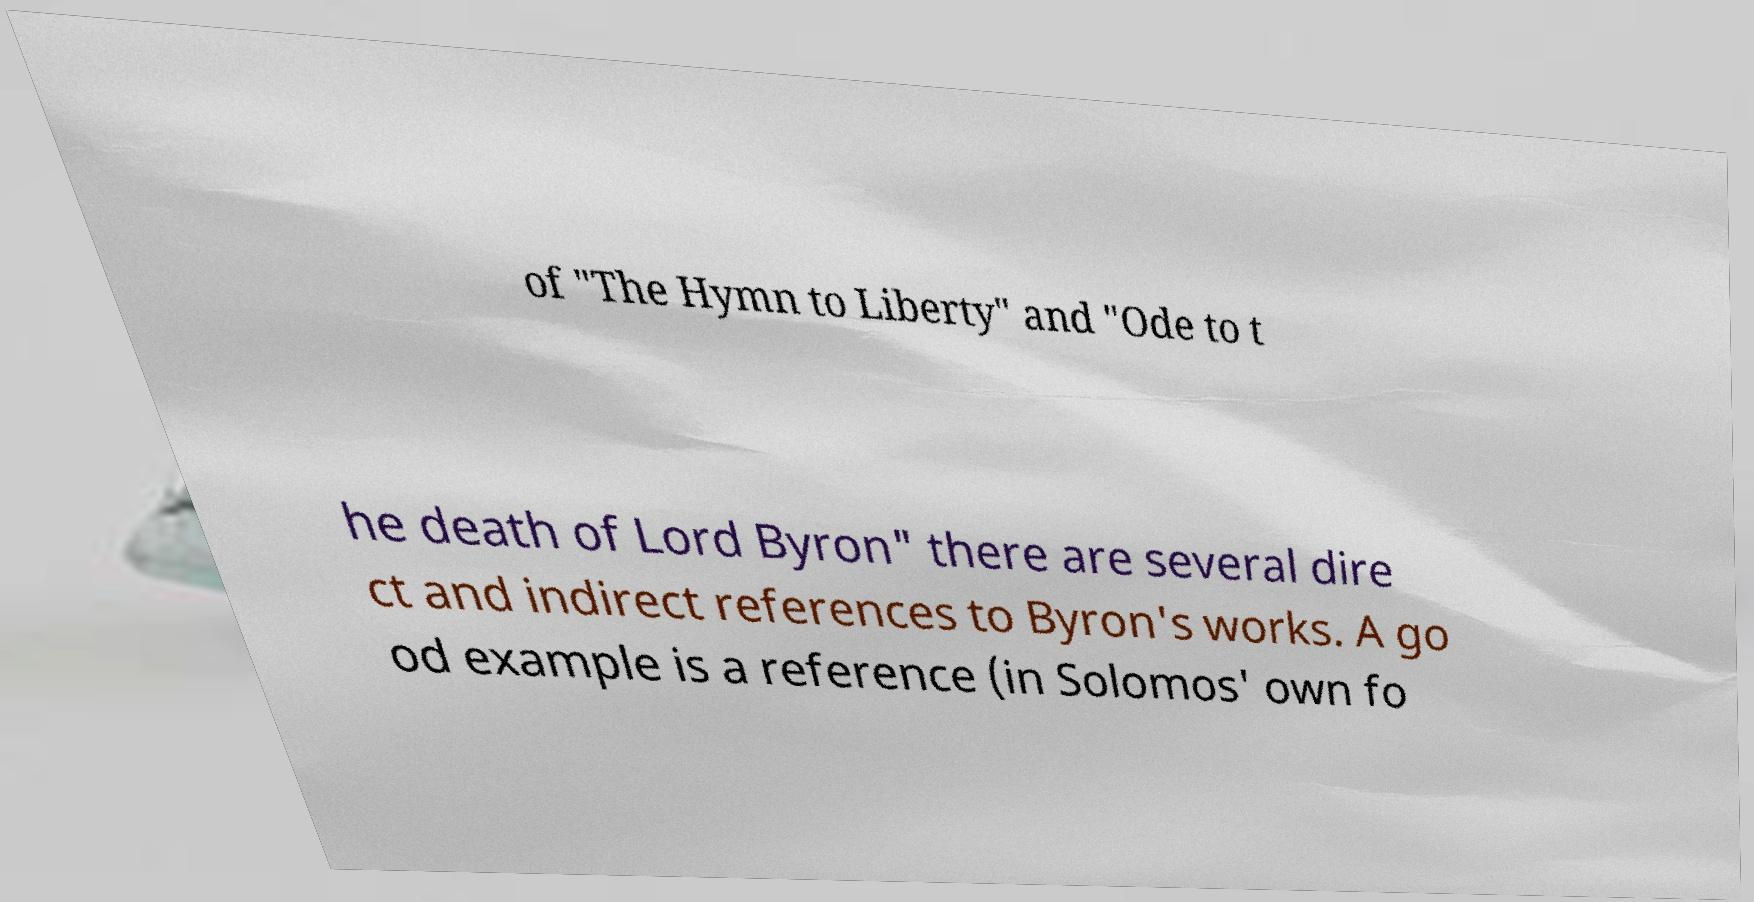Can you read and provide the text displayed in the image?This photo seems to have some interesting text. Can you extract and type it out for me? of "The Hymn to Liberty" and "Ode to t he death of Lord Byron" there are several dire ct and indirect references to Byron's works. A go od example is a reference (in Solomos' own fo 